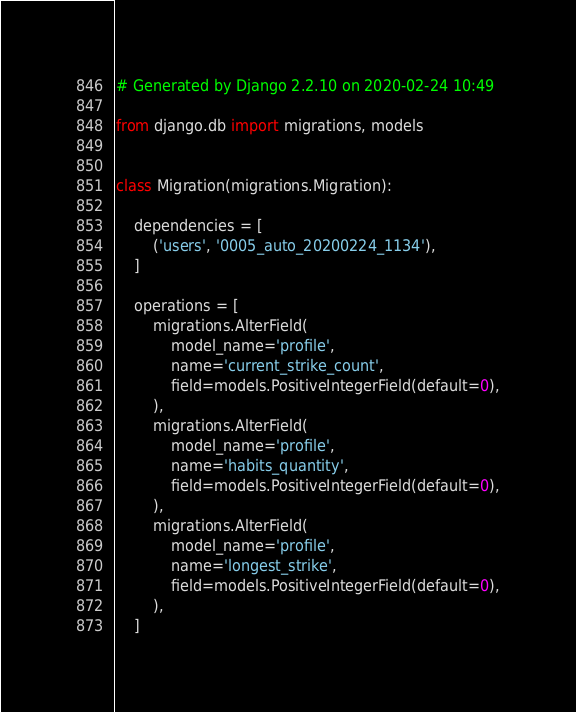Convert code to text. <code><loc_0><loc_0><loc_500><loc_500><_Python_># Generated by Django 2.2.10 on 2020-02-24 10:49

from django.db import migrations, models


class Migration(migrations.Migration):

    dependencies = [
        ('users', '0005_auto_20200224_1134'),
    ]

    operations = [
        migrations.AlterField(
            model_name='profile',
            name='current_strike_count',
            field=models.PositiveIntegerField(default=0),
        ),
        migrations.AlterField(
            model_name='profile',
            name='habits_quantity',
            field=models.PositiveIntegerField(default=0),
        ),
        migrations.AlterField(
            model_name='profile',
            name='longest_strike',
            field=models.PositiveIntegerField(default=0),
        ),
    ]
</code> 